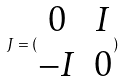<formula> <loc_0><loc_0><loc_500><loc_500>J = ( \begin{matrix} 0 & I \\ - I & 0 \end{matrix} )</formula> 